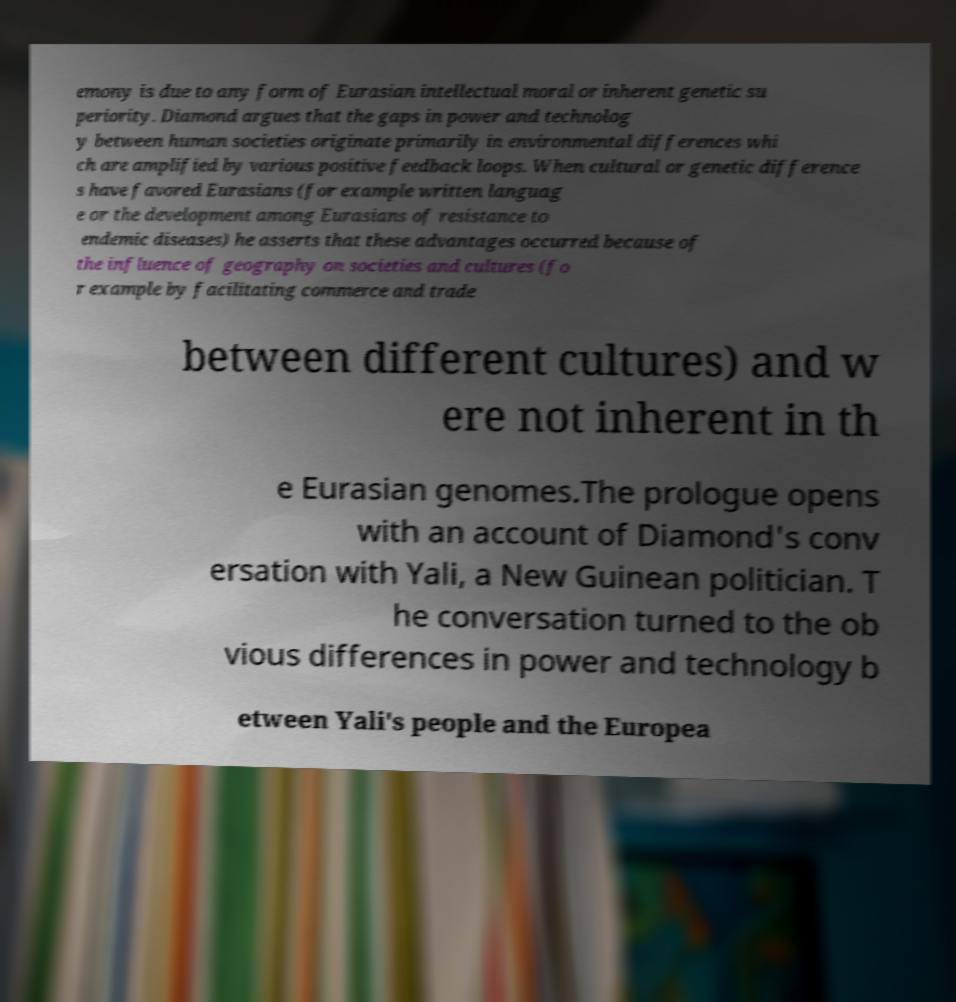Please read and relay the text visible in this image. What does it say? emony is due to any form of Eurasian intellectual moral or inherent genetic su periority. Diamond argues that the gaps in power and technolog y between human societies originate primarily in environmental differences whi ch are amplified by various positive feedback loops. When cultural or genetic difference s have favored Eurasians (for example written languag e or the development among Eurasians of resistance to endemic diseases) he asserts that these advantages occurred because of the influence of geography on societies and cultures (fo r example by facilitating commerce and trade between different cultures) and w ere not inherent in th e Eurasian genomes.The prologue opens with an account of Diamond's conv ersation with Yali, a New Guinean politician. T he conversation turned to the ob vious differences in power and technology b etween Yali's people and the Europea 